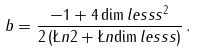Convert formula to latex. <formula><loc_0><loc_0><loc_500><loc_500>b = \frac { - 1 + 4 \dim l e s s { s } ^ { 2 } } { 2 \left ( \L n { 2 } + \L n { \dim l e s s { s } } \right ) } \, .</formula> 